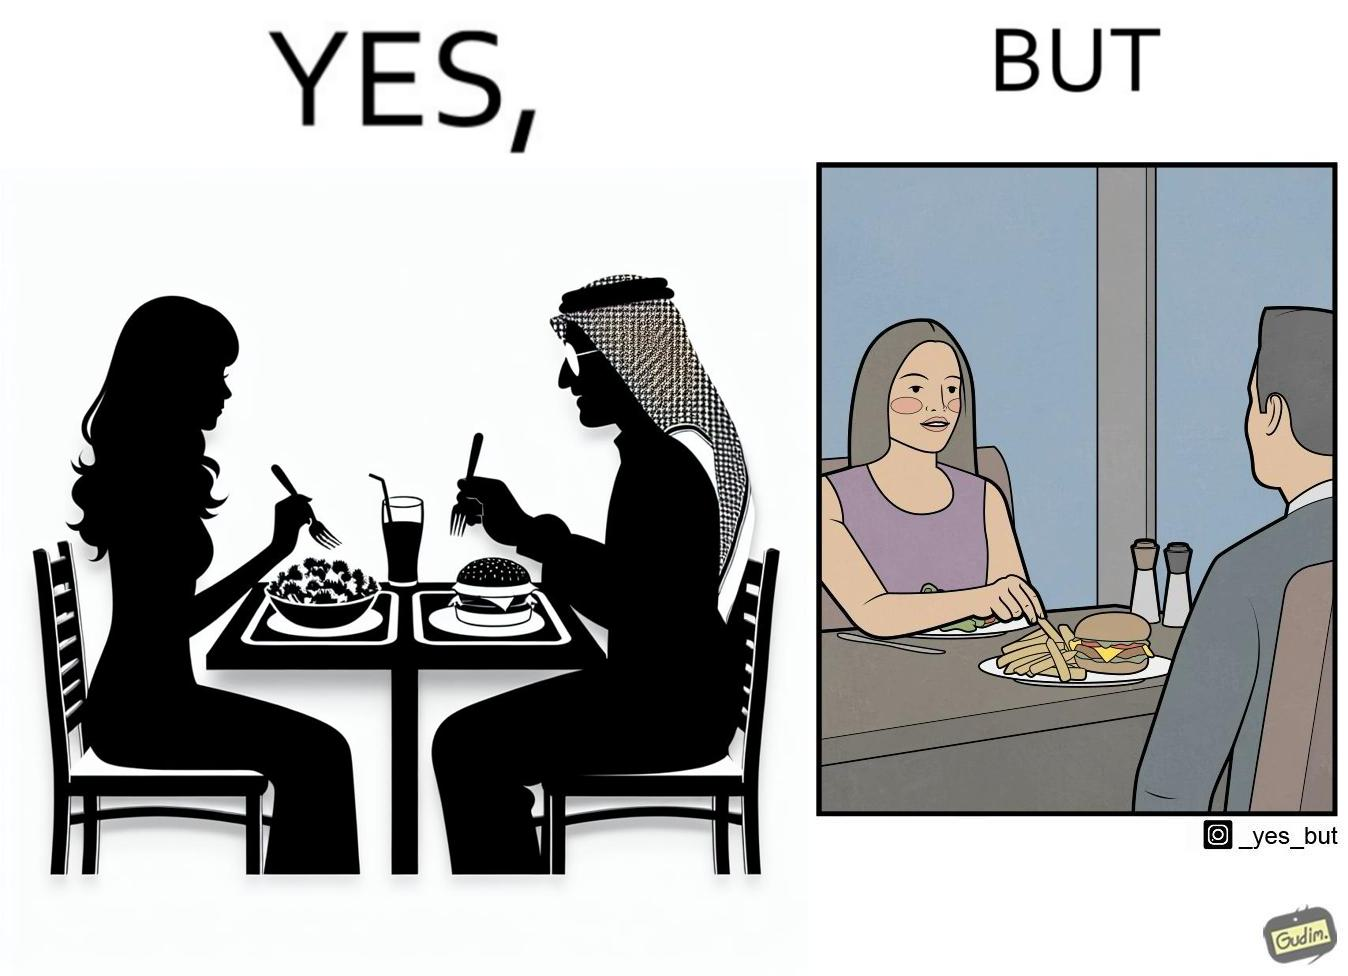Is this a satirical image? Yes, this image is satirical. 